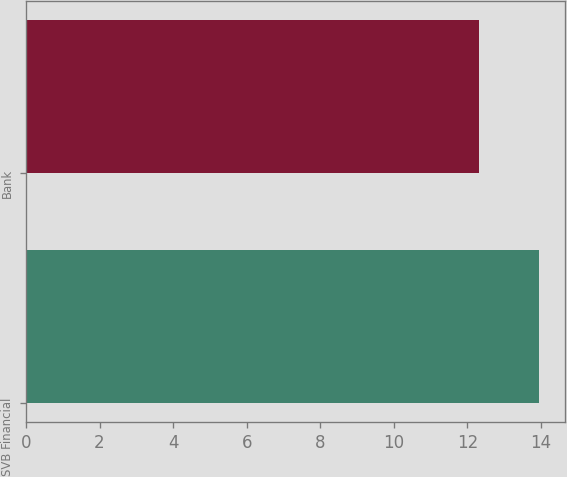<chart> <loc_0><loc_0><loc_500><loc_500><bar_chart><fcel>SVB Financial<fcel>Bank<nl><fcel>13.95<fcel>12.33<nl></chart> 